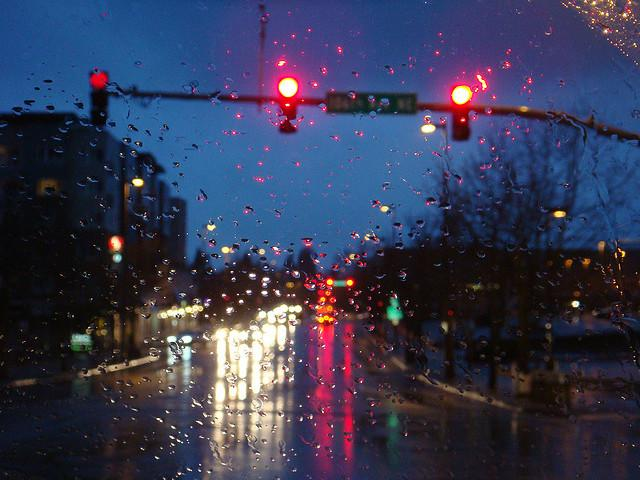What's seen on the window? raindrops 